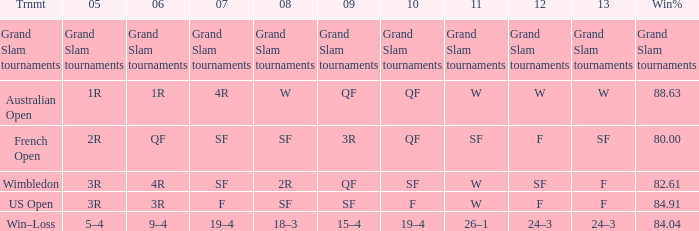What in 2007 has a 2008 of sf, and a 2010 of f? F. Would you be able to parse every entry in this table? {'header': ['Trnmt', '05', '06', '07', '08', '09', '10', '11', '12', '13', 'Win%'], 'rows': [['Grand Slam tournaments', 'Grand Slam tournaments', 'Grand Slam tournaments', 'Grand Slam tournaments', 'Grand Slam tournaments', 'Grand Slam tournaments', 'Grand Slam tournaments', 'Grand Slam tournaments', 'Grand Slam tournaments', 'Grand Slam tournaments', 'Grand Slam tournaments'], ['Australian Open', '1R', '1R', '4R', 'W', 'QF', 'QF', 'W', 'W', 'W', '88.63'], ['French Open', '2R', 'QF', 'SF', 'SF', '3R', 'QF', 'SF', 'F', 'SF', '80.00'], ['Wimbledon', '3R', '4R', 'SF', '2R', 'QF', 'SF', 'W', 'SF', 'F', '82.61'], ['US Open', '3R', '3R', 'F', 'SF', 'SF', 'F', 'W', 'F', 'F', '84.91'], ['Win–Loss', '5–4', '9–4', '19–4', '18–3', '15–4', '19–4', '26–1', '24–3', '24–3', '84.04']]} 